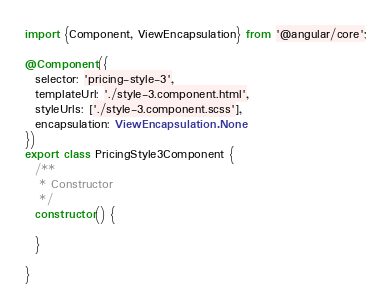<code> <loc_0><loc_0><loc_500><loc_500><_TypeScript_>import {Component, ViewEncapsulation} from '@angular/core';

@Component({
  selector: 'pricing-style-3',
  templateUrl: './style-3.component.html',
  styleUrls: ['./style-3.component.scss'],
  encapsulation: ViewEncapsulation.None
})
export class PricingStyle3Component {
  /**
   * Constructor
   */
  constructor() {

  }

}
</code> 